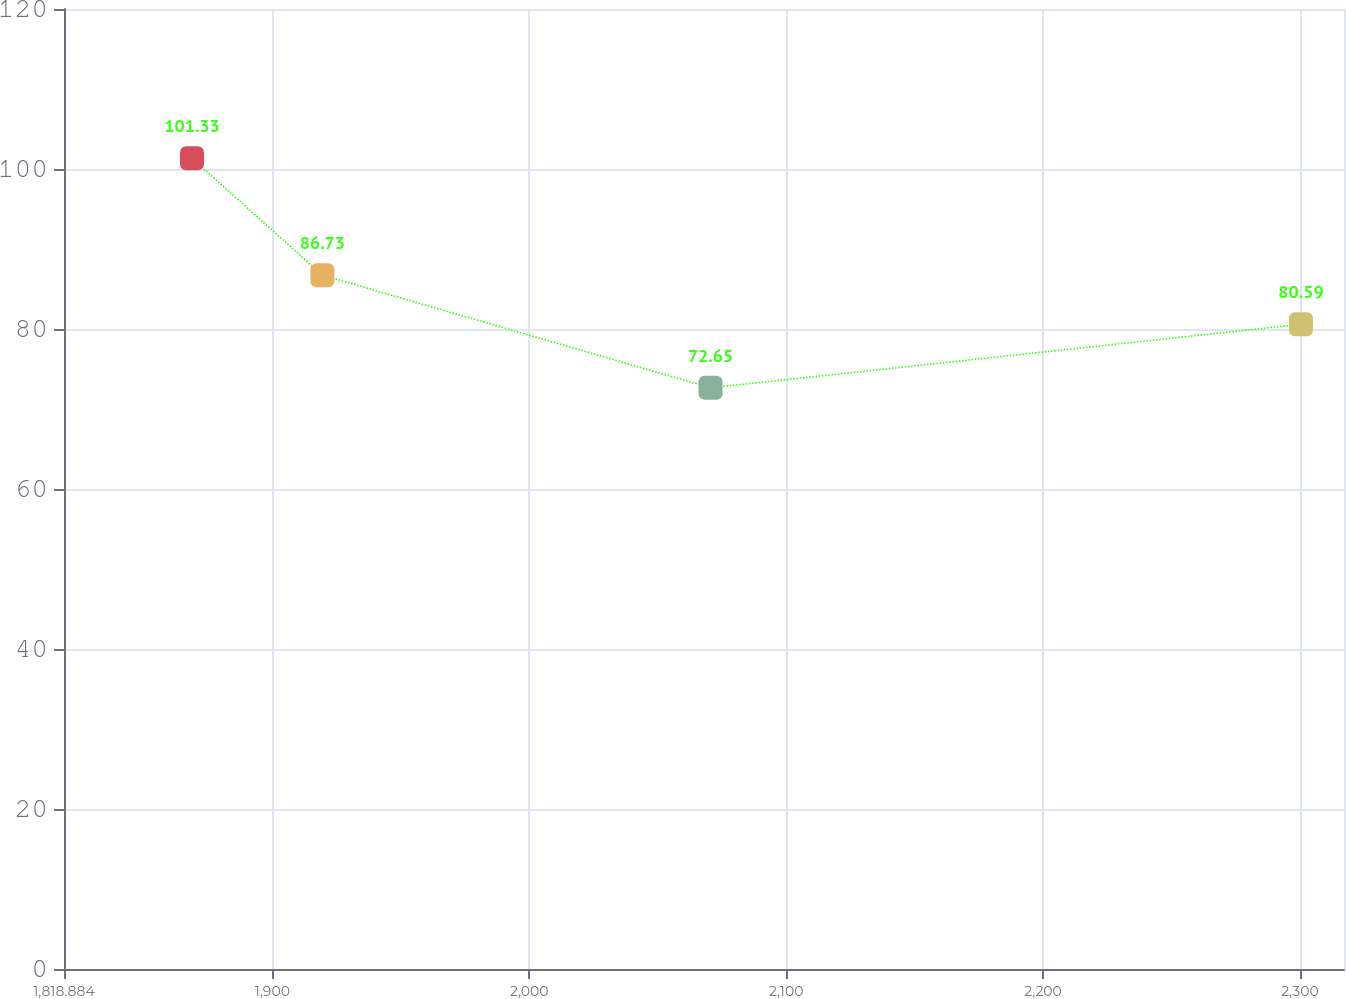Convert chart. <chart><loc_0><loc_0><loc_500><loc_500><line_chart><ecel><fcel>(in millions)<nl><fcel>1868.71<fcel>101.33<nl><fcel>1919.46<fcel>86.73<nl><fcel>2070.56<fcel>72.65<nl><fcel>2300.39<fcel>80.59<nl><fcel>2366.97<fcel>66.09<nl></chart> 